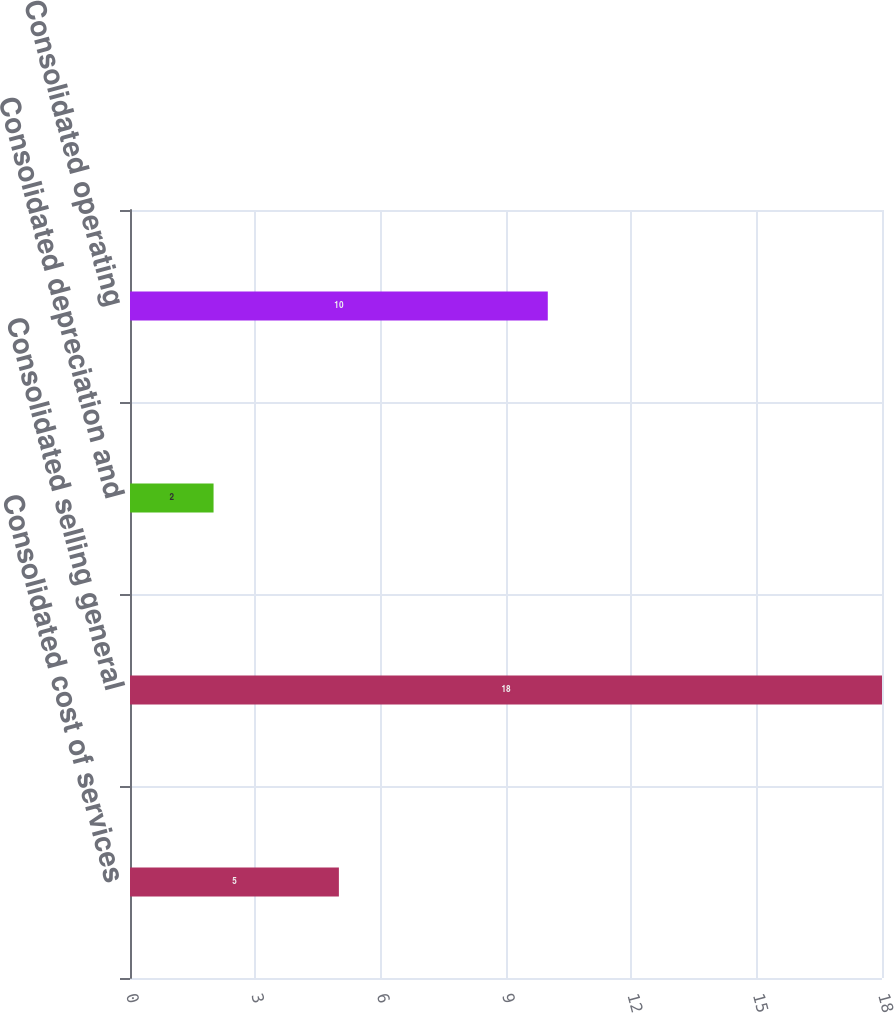Convert chart. <chart><loc_0><loc_0><loc_500><loc_500><bar_chart><fcel>Consolidated cost of services<fcel>Consolidated selling general<fcel>Consolidated depreciation and<fcel>Consolidated operating<nl><fcel>5<fcel>18<fcel>2<fcel>10<nl></chart> 